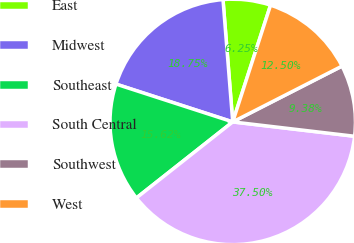<chart> <loc_0><loc_0><loc_500><loc_500><pie_chart><fcel>East<fcel>Midwest<fcel>Southeast<fcel>South Central<fcel>Southwest<fcel>West<nl><fcel>6.25%<fcel>18.75%<fcel>15.62%<fcel>37.5%<fcel>9.38%<fcel>12.5%<nl></chart> 